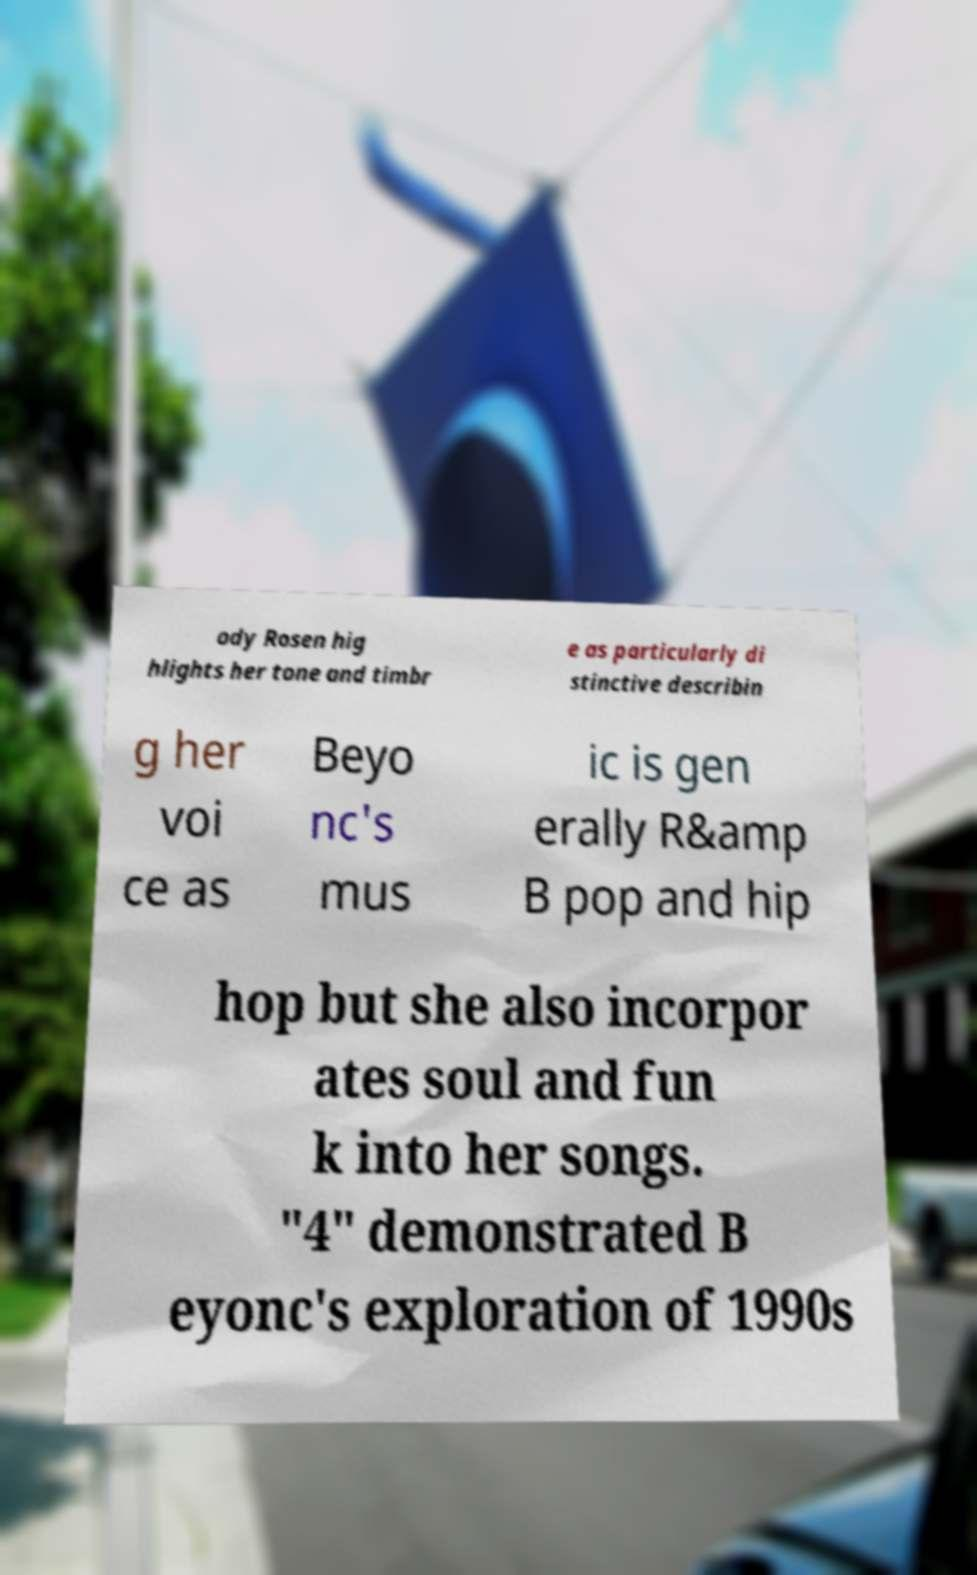Could you assist in decoding the text presented in this image and type it out clearly? ody Rosen hig hlights her tone and timbr e as particularly di stinctive describin g her voi ce as Beyo nc's mus ic is gen erally R&amp B pop and hip hop but she also incorpor ates soul and fun k into her songs. "4" demonstrated B eyonc's exploration of 1990s 